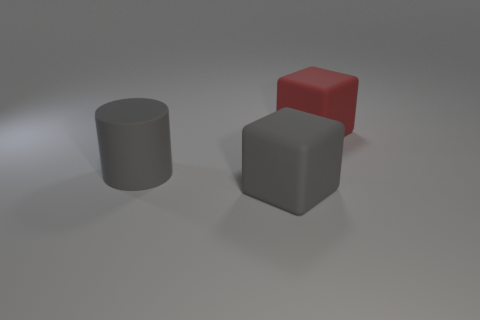There is a object that is the same color as the rubber cylinder; what is it made of?
Offer a very short reply. Rubber. Does the large gray matte object that is in front of the gray cylinder have the same shape as the large red thing?
Your response must be concise. Yes. What color is the other large thing that is the same shape as the red rubber object?
Provide a succinct answer. Gray. The gray object that is the same shape as the large red matte object is what size?
Your answer should be very brief. Large. There is a big cube that is in front of the red thing; is its color the same as the cylinder?
Your answer should be very brief. Yes. There is a cylinder; is its color the same as the cube behind the large gray rubber block?
Give a very brief answer. No. There is a cylinder; are there any big things on the right side of it?
Offer a very short reply. Yes. There is a red block that is the same size as the gray matte block; what material is it?
Ensure brevity in your answer.  Rubber. How many things are things that are in front of the red block or large red rubber things?
Provide a short and direct response. 3. Are there an equal number of red objects that are on the left side of the red object and large brown rubber things?
Your answer should be compact. Yes. 